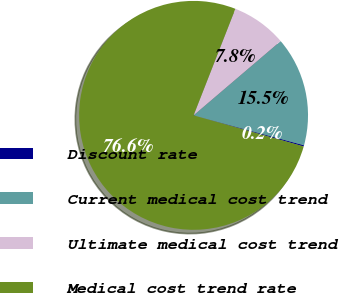<chart> <loc_0><loc_0><loc_500><loc_500><pie_chart><fcel>Discount rate<fcel>Current medical cost trend<fcel>Ultimate medical cost trend<fcel>Medical cost trend rate<nl><fcel>0.17%<fcel>15.45%<fcel>7.81%<fcel>76.56%<nl></chart> 